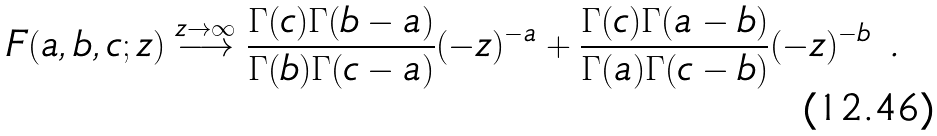Convert formula to latex. <formula><loc_0><loc_0><loc_500><loc_500>F ( a , b , c ; z ) \stackrel { z \to \infty } { \longrightarrow } \frac { \Gamma ( c ) \Gamma ( b - a ) } { \Gamma ( b ) \Gamma ( c - a ) } ( - z ) ^ { - a } + \frac { \Gamma ( c ) \Gamma ( a - b ) } { \Gamma ( a ) \Gamma ( c - b ) } ( - z ) ^ { - b } \ .</formula> 